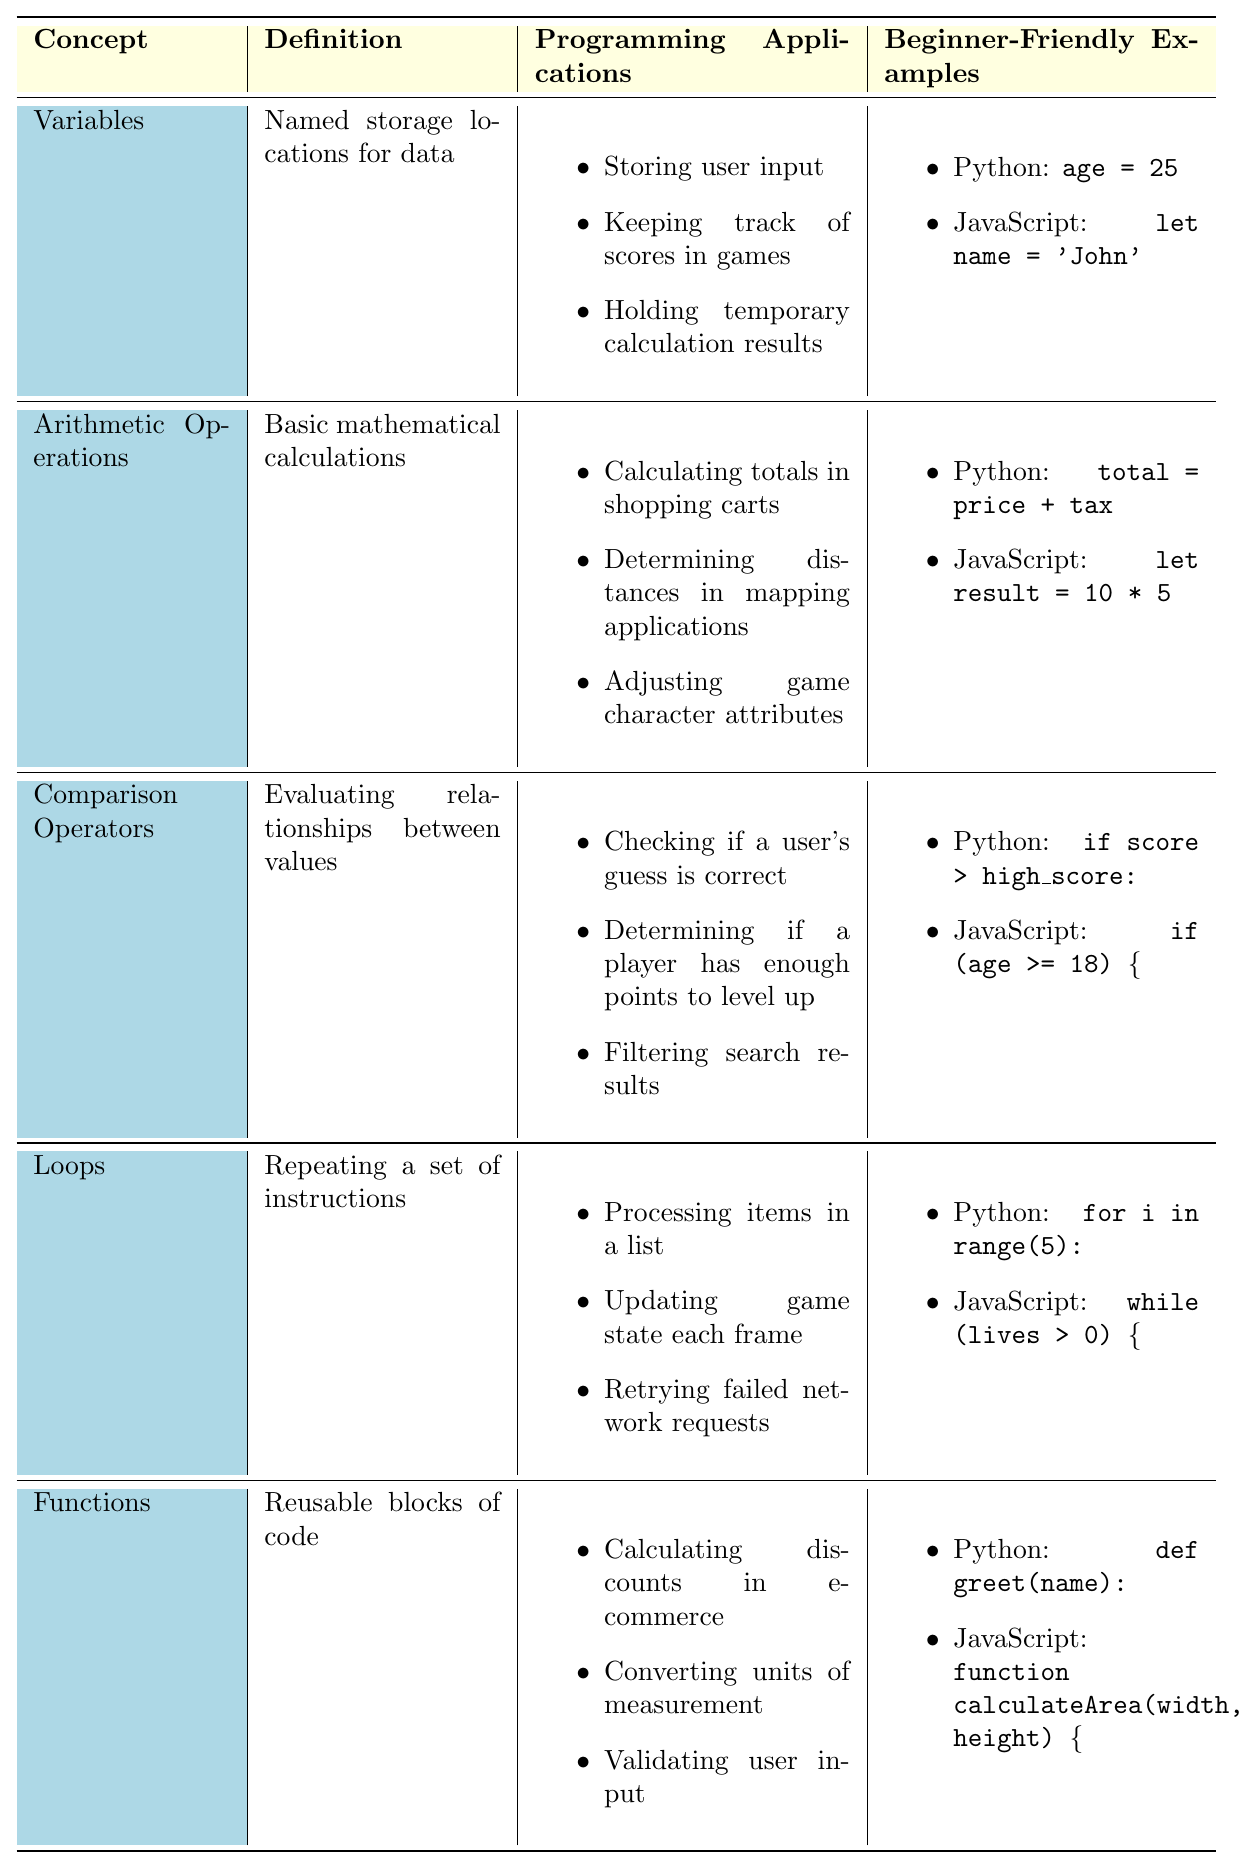What is the definition of Variables? The table states that Variables are "Named storage locations for data." This definition is clear and directly accessible in the table provided.
Answer: Named storage locations for data What are two examples of Variables in programming languages listed in the table? The table provides examples for each programming language. For Python, the example is "age = 25," and for JavaScript, it is "let name = 'John'." These specific pairs can be directly found in the relevant section.
Answer: age = 25 and let name = 'John' List one programming application of Arithmetic Operations. The table contains multiple applications under the Arithmetic Operations concept. One example listed is "Calculating totals in shopping carts," which is easy to locate in the table.
Answer: Calculating totals in shopping carts Are Functions reusable blocks of code? The definition for Functions states that they are "Reusable blocks of code." This statement directly affirms the question based on the provided data.
Answer: Yes How many programming applications are listed for Loops? In the table under Loops, there are three programming applications specified: processing items, updating game states, and retrying network requests. By counting these items, we find the total is three.
Answer: Three What is the relationship between Comparison Operators and user input? The table mentions multiple applications of Comparison Operators, including "Checking if a user's guess is correct." This indicates that there is a direct relationship between the concept and handling user input.
Answer: There is a direct relationship If we combine the programming applications of Variables and Functions, what is the total count? The table lists three programming applications for Variables and three for Functions. Adding these together gives 3 (Variables) + 3 (Functions) = 6 total applications.
Answer: Six Which mathematical concept has the longest definition? By comparing all the definitions in the table, we see that the definition of Comparison Operators, which is "Evaluating relationships between values," has the most words. It can be identified by counting characters or words in all the definitions.
Answer: Comparison Operators Identify one programming application related to Arithmetic Operations and describe how it might be applied. The table provides "Determining distances in mapping applications" as one application. This could involve using various arithmetic operations to calculate the distance between two points based on their coordinates.
Answer: Determining distances in mapping applications What is the difference between the number of programming applications for Loops and Functions? The table lists three applications for Loops and three for Functions. Therefore, the difference in the count is 3 (Loops) - 3 (Functions) = 0. This shows both concepts have equal applications.
Answer: Zero 